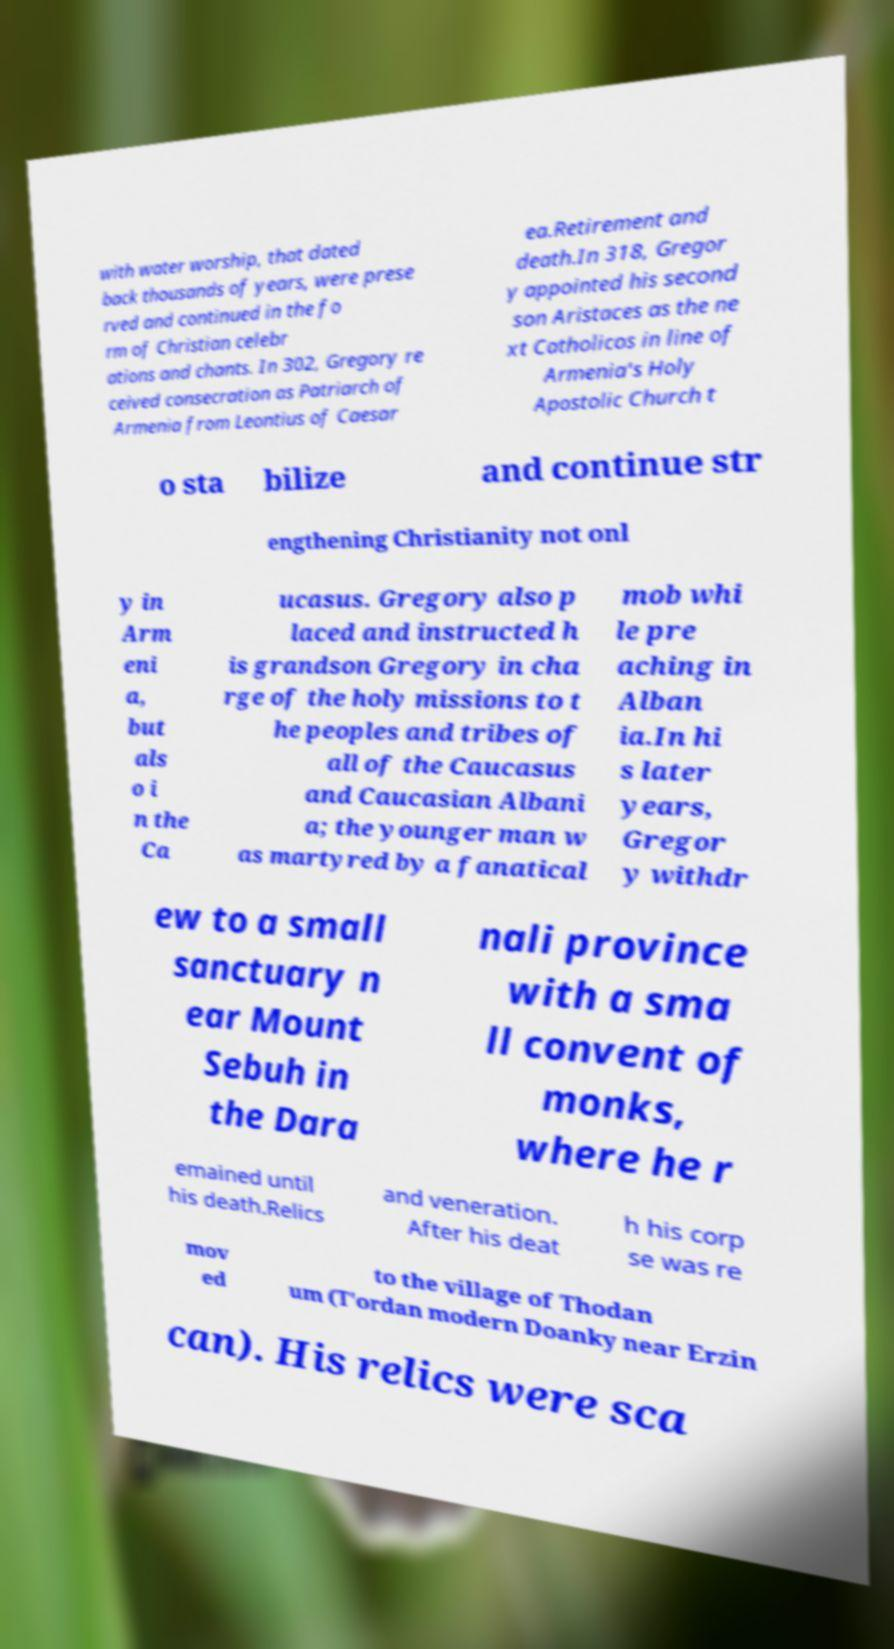I need the written content from this picture converted into text. Can you do that? with water worship, that dated back thousands of years, were prese rved and continued in the fo rm of Christian celebr ations and chants. In 302, Gregory re ceived consecration as Patriarch of Armenia from Leontius of Caesar ea.Retirement and death.In 318, Gregor y appointed his second son Aristaces as the ne xt Catholicos in line of Armenia's Holy Apostolic Church t o sta bilize and continue str engthening Christianity not onl y in Arm eni a, but als o i n the Ca ucasus. Gregory also p laced and instructed h is grandson Gregory in cha rge of the holy missions to t he peoples and tribes of all of the Caucasus and Caucasian Albani a; the younger man w as martyred by a fanatical mob whi le pre aching in Alban ia.In hi s later years, Gregor y withdr ew to a small sanctuary n ear Mount Sebuh in the Dara nali province with a sma ll convent of monks, where he r emained until his death.Relics and veneration. After his deat h his corp se was re mov ed to the village of Thodan um (T'ordan modern Doanky near Erzin can). His relics were sca 